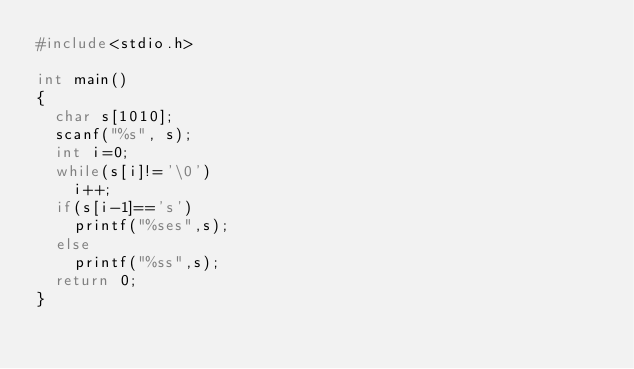Convert code to text. <code><loc_0><loc_0><loc_500><loc_500><_C++_>#include<stdio.h>

int main()
{
  char s[1010];
  scanf("%s", s);
  int i=0;
  while(s[i]!='\0')
    i++;
  if(s[i-1]=='s')
    printf("%ses",s);
  else
    printf("%ss",s);
  return 0;
}</code> 